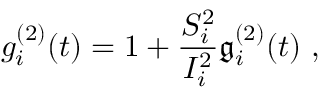<formula> <loc_0><loc_0><loc_500><loc_500>g _ { i } ^ { ( 2 ) } ( t ) = 1 + \frac { S _ { i } ^ { 2 } } { I _ { i } ^ { 2 } } \mathfrak { g } _ { i } ^ { ( 2 ) } ( t ) \ ,</formula> 